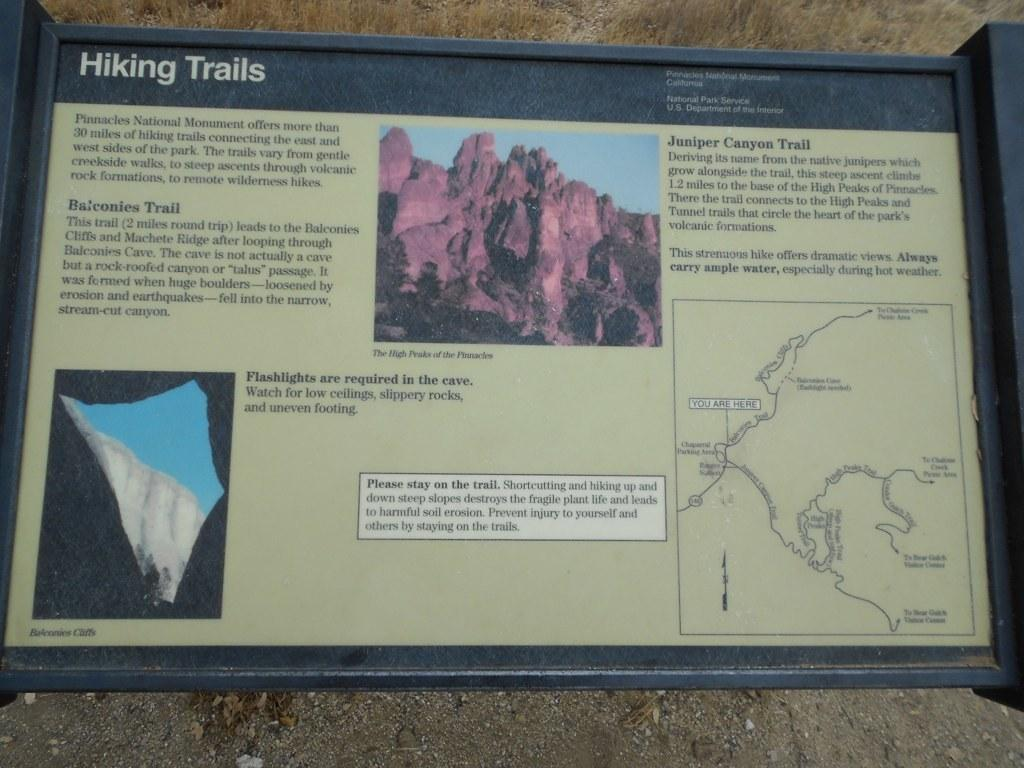<image>
Create a compact narrative representing the image presented. A National Park Service sign provides information about hiking trails located in Pinnacles National Monument. 